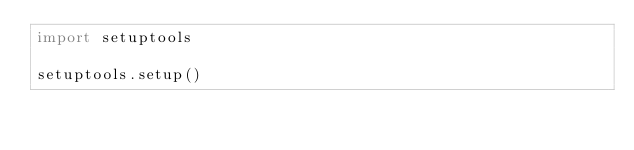<code> <loc_0><loc_0><loc_500><loc_500><_Python_>import setuptools

setuptools.setup()
</code> 